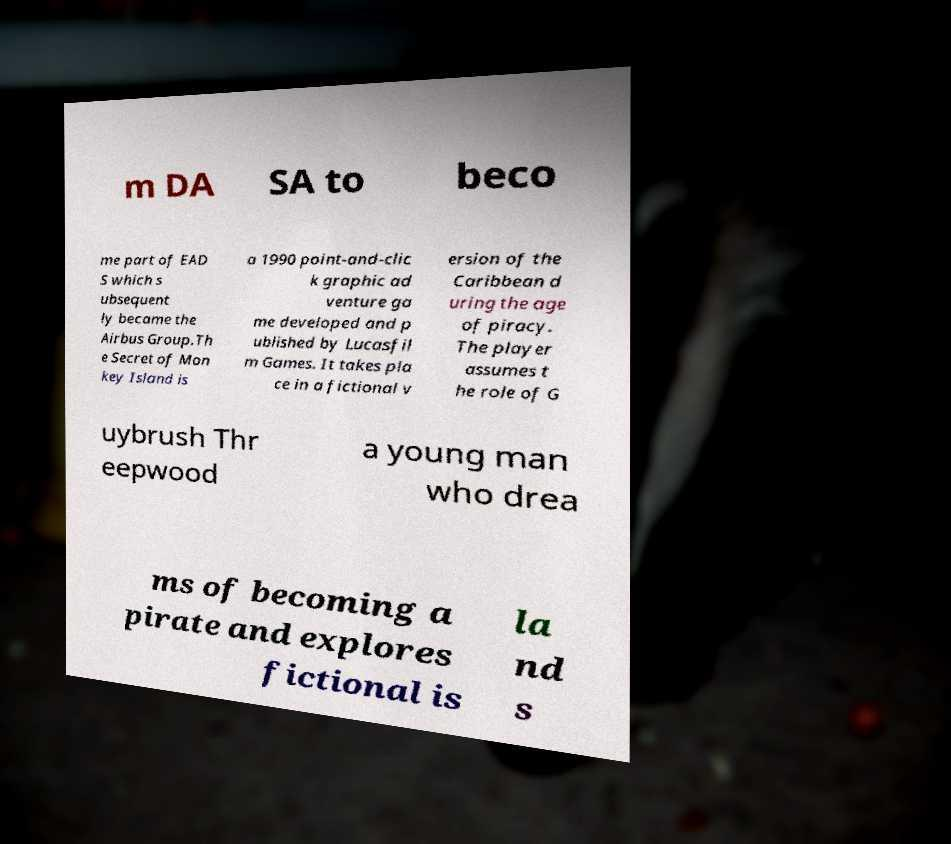Please identify and transcribe the text found in this image. m DA SA to beco me part of EAD S which s ubsequent ly became the Airbus Group.Th e Secret of Mon key Island is a 1990 point-and-clic k graphic ad venture ga me developed and p ublished by Lucasfil m Games. It takes pla ce in a fictional v ersion of the Caribbean d uring the age of piracy. The player assumes t he role of G uybrush Thr eepwood a young man who drea ms of becoming a pirate and explores fictional is la nd s 